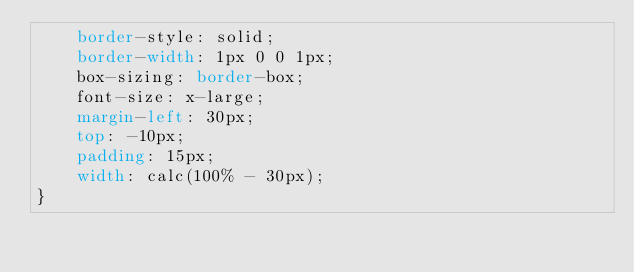Convert code to text. <code><loc_0><loc_0><loc_500><loc_500><_CSS_>    border-style: solid;
    border-width: 1px 0 0 1px;
    box-sizing: border-box;
    font-size: x-large;
    margin-left: 30px;
    top: -10px;
    padding: 15px;
    width: calc(100% - 30px);
}</code> 